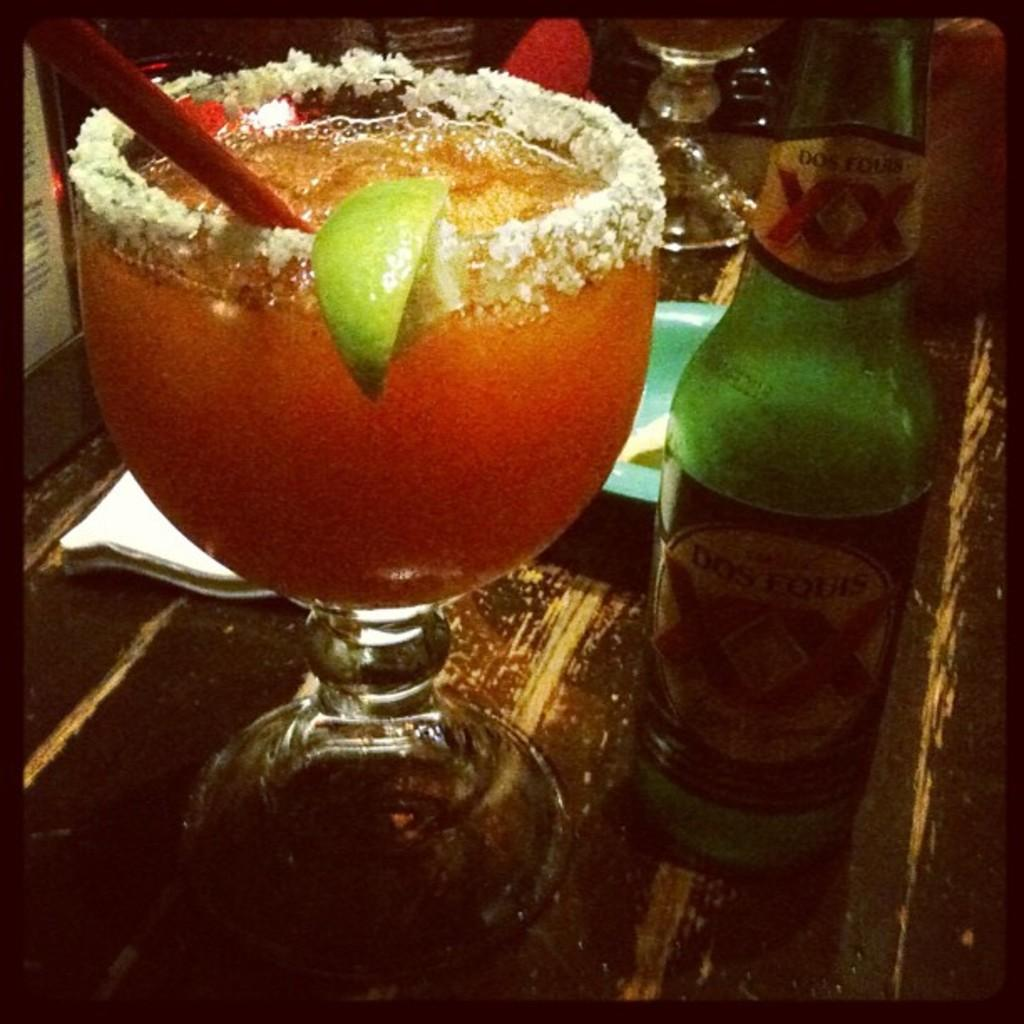Provide a one-sentence caption for the provided image. A Dos Equis green colored bottle of beer sitting on a counter next to a margarita. 